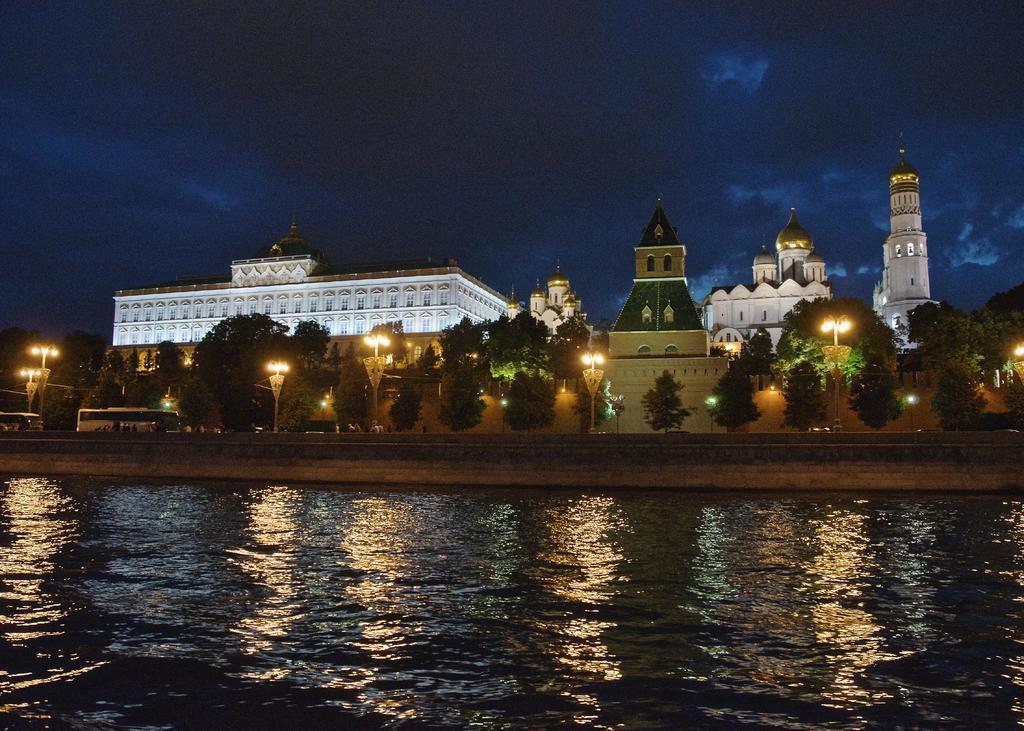How would you summarize this image in a sentence or two? In the center of the image we can see a trees, buildings, buses and some persons, electric light, wall are present. At the bottom of the image water is there. At the top of the image clouds are present in the sky. 